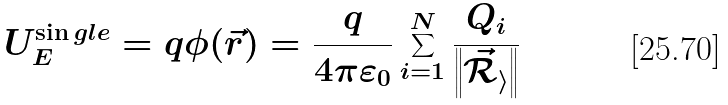<formula> <loc_0><loc_0><loc_500><loc_500>U _ { E } ^ { \sin g l e } = q \phi ( { \vec { r } } ) = { \frac { q } { 4 \pi \varepsilon _ { 0 } } } \sum _ { i = 1 } ^ { N } { \frac { Q _ { i } } { \left \| { \mathcal { { \vec { R } } _ { i } } } \right \| } }</formula> 